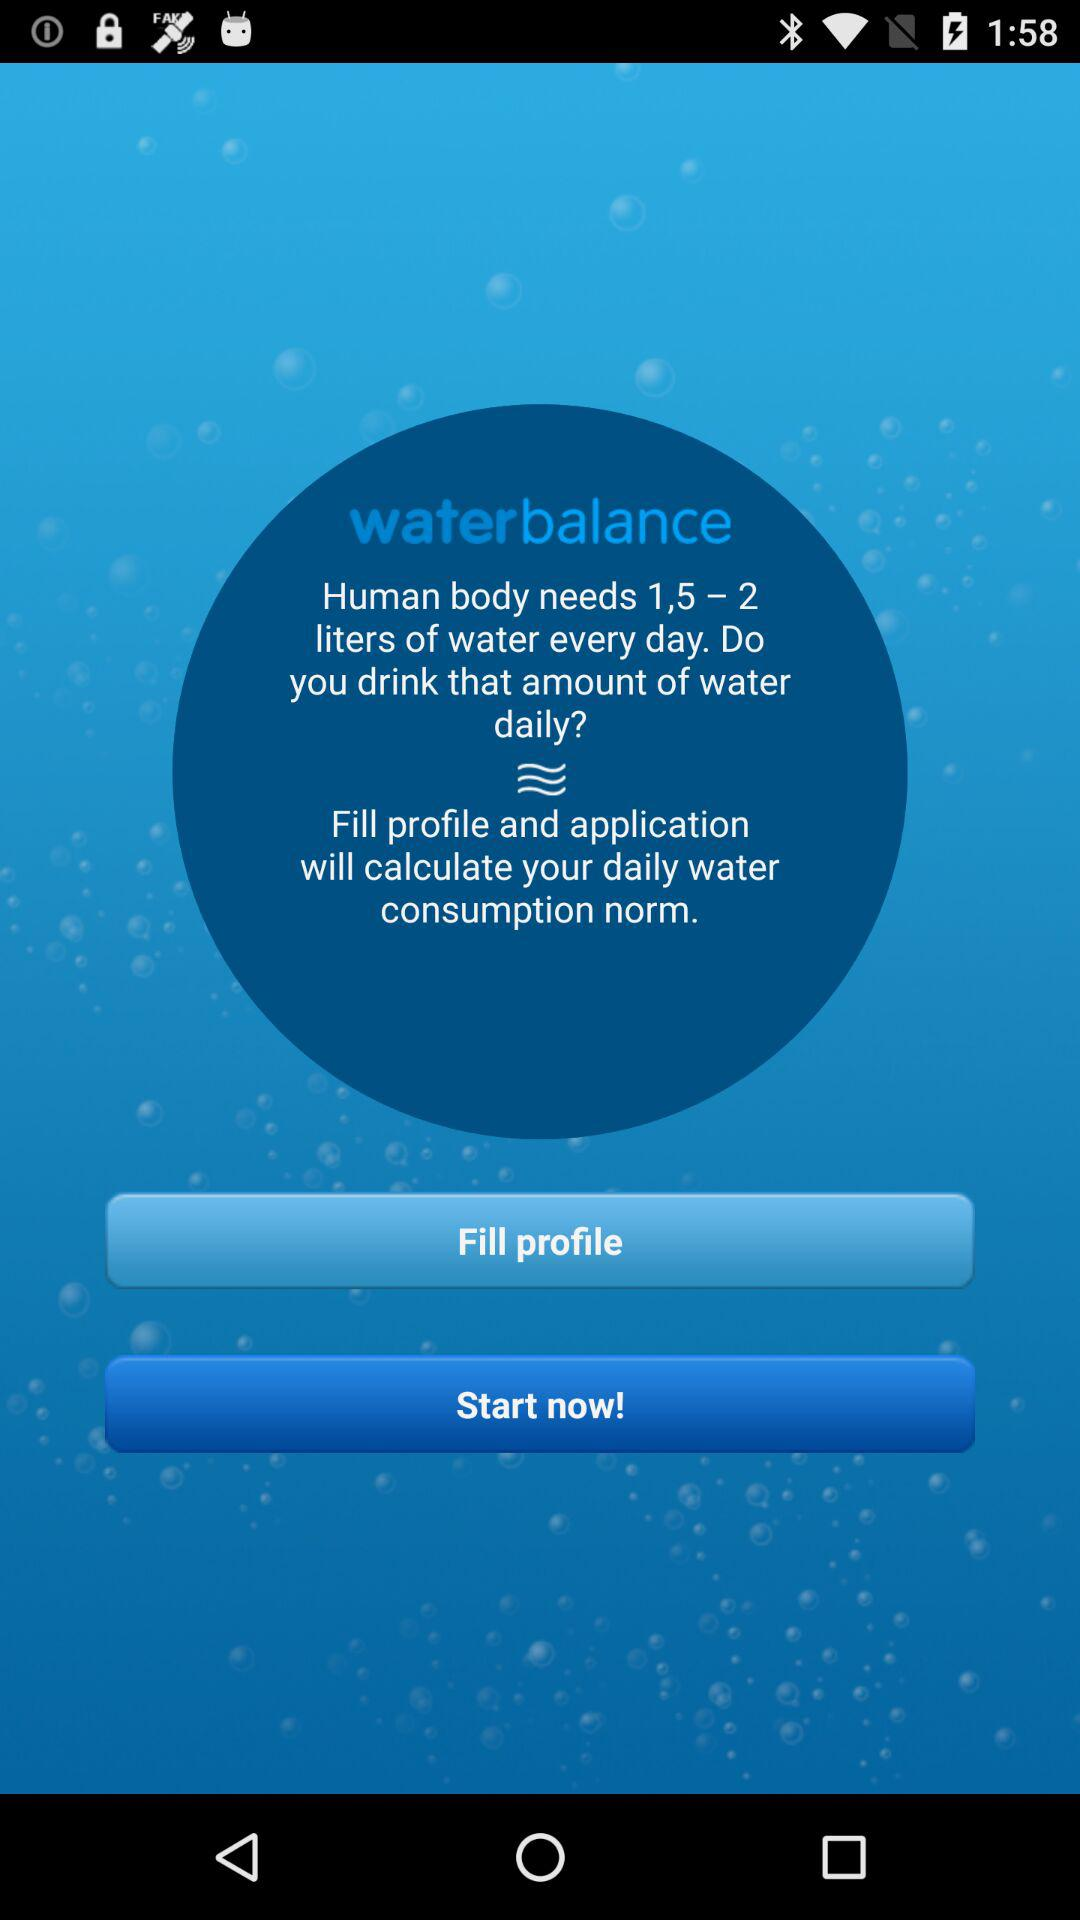How much water does the human body need? The human body needs 1.5 – 2 liters. 